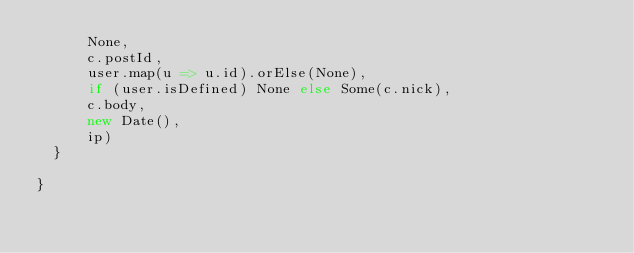Convert code to text. <code><loc_0><loc_0><loc_500><loc_500><_Scala_>      None,
      c.postId,
      user.map(u => u.id).orElse(None),
      if (user.isDefined) None else Some(c.nick),
      c.body,
      new Date(),
      ip)
  }

}
</code> 